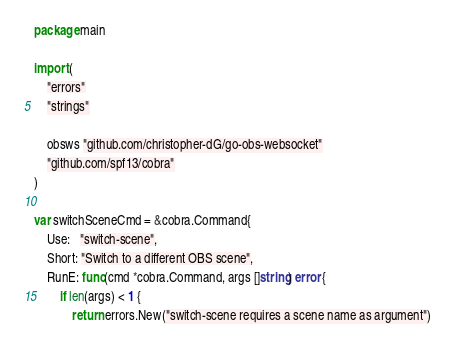Convert code to text. <code><loc_0><loc_0><loc_500><loc_500><_Go_>package main

import (
	"errors"
	"strings"

	obsws "github.com/christopher-dG/go-obs-websocket"
	"github.com/spf13/cobra"
)

var switchSceneCmd = &cobra.Command{
	Use:   "switch-scene",
	Short: "Switch to a different OBS scene",
	RunE: func(cmd *cobra.Command, args []string) error {
		if len(args) < 1 {
			return errors.New("switch-scene requires a scene name as argument")</code> 